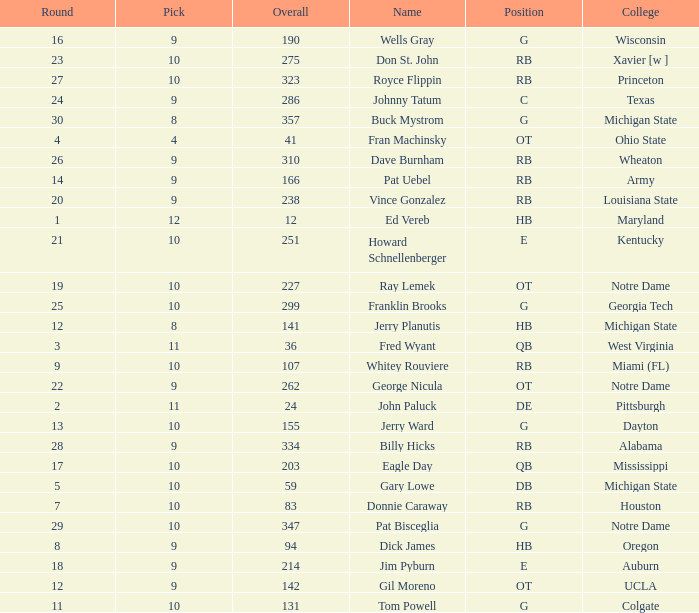What is the highest overall pick number for george nicula who had a pick smaller than 9? None. 